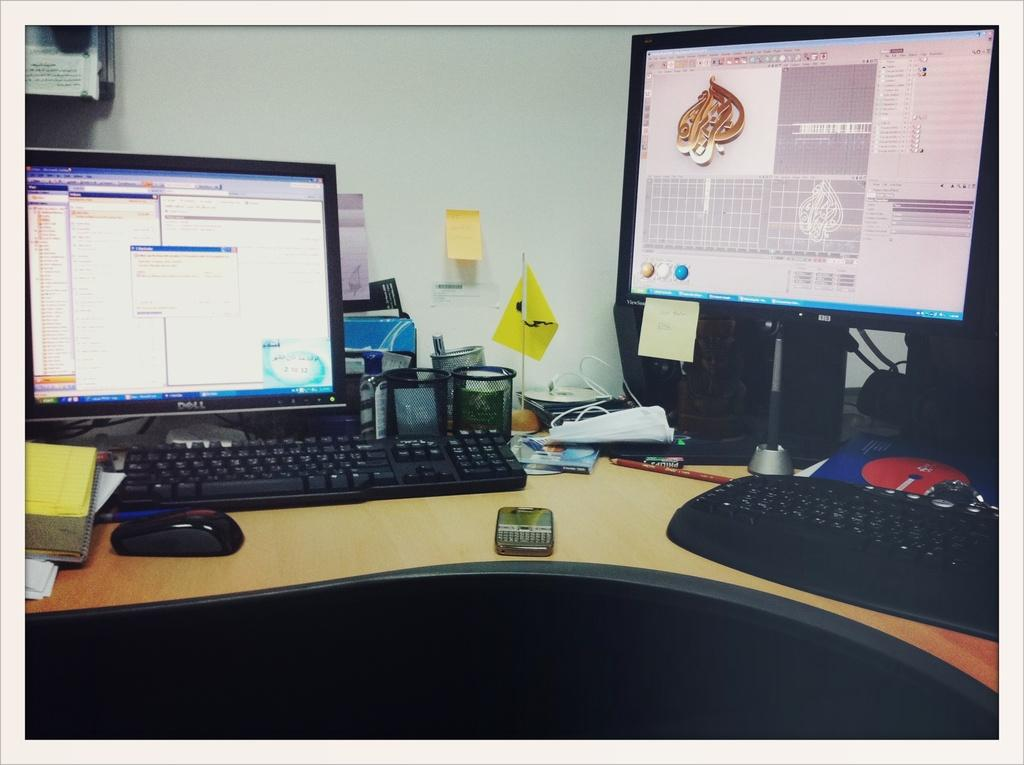What objects can be seen on the table in the image? There is a mobile, a mouse, a keyboard, a monitor, a container, a flag, and a pen on the table in the image. What is the purpose of the container on the table? The purpose of the container on the table is not specified in the image. Where is the note located in the image? The note is on a wall in the image. What is the screen in the image displaying? The facts provided do not specify what the screen is displaying. How many friends can be seen interacting with the mouse in the image? There are no friends interacting with the mouse in the image; it is a standalone object on the table. 